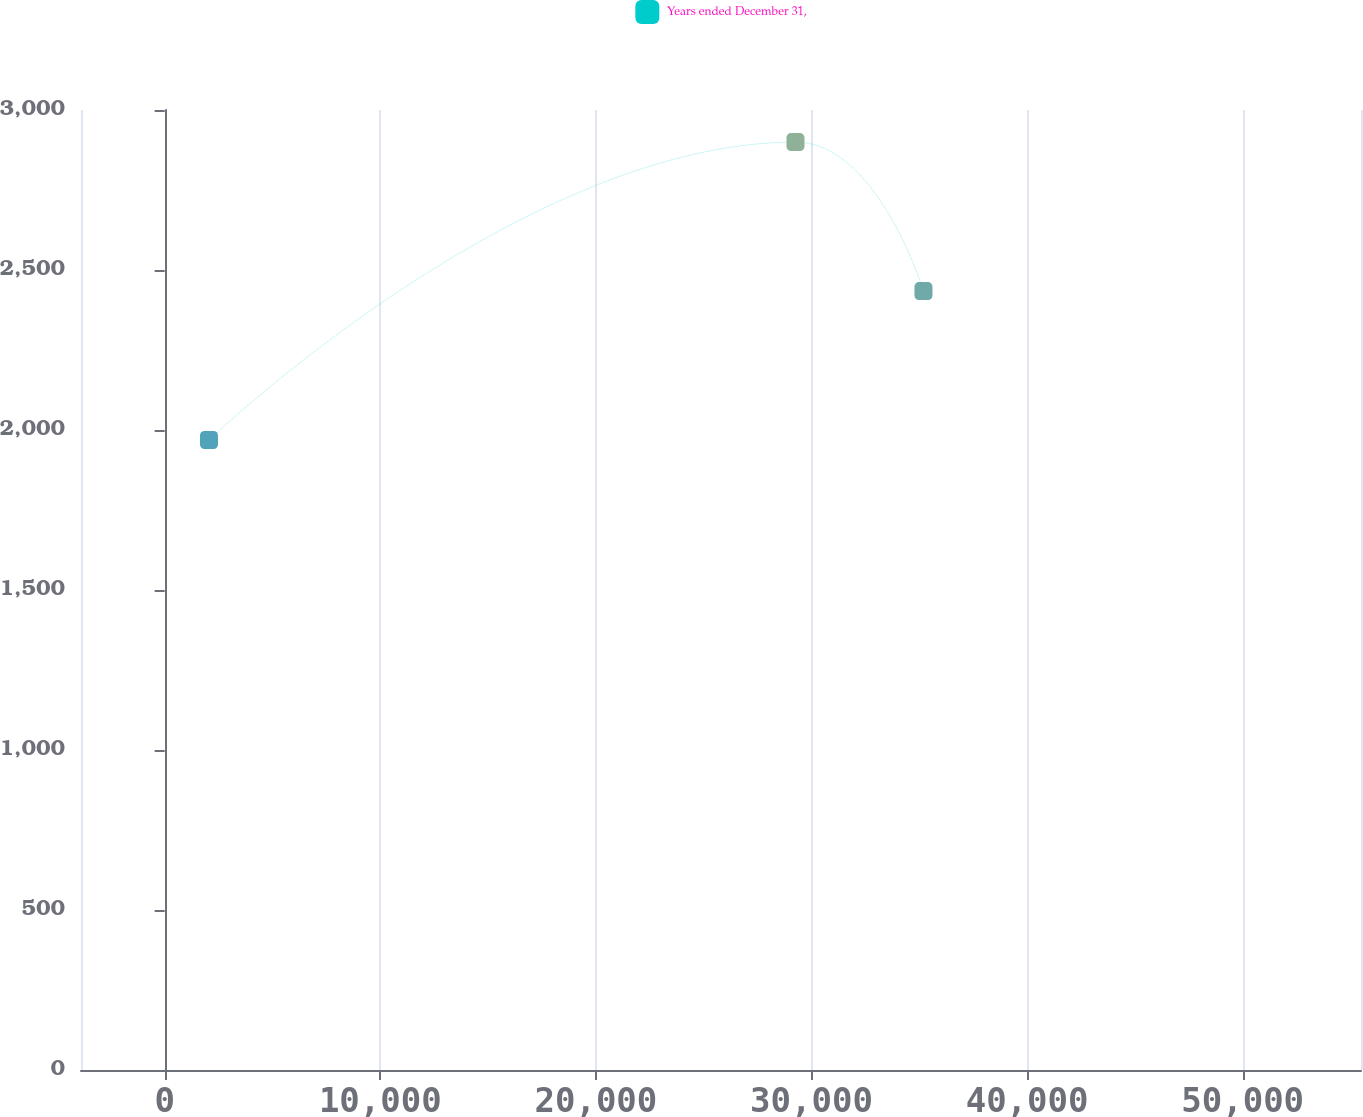Convert chart. <chart><loc_0><loc_0><loc_500><loc_500><line_chart><ecel><fcel>Years ended December 31,<nl><fcel>2055.23<fcel>1968.58<nl><fcel>29257.4<fcel>2899.66<nl><fcel>35194.3<fcel>2434.12<nl><fcel>61424.8<fcel>6624.01<nl></chart> 